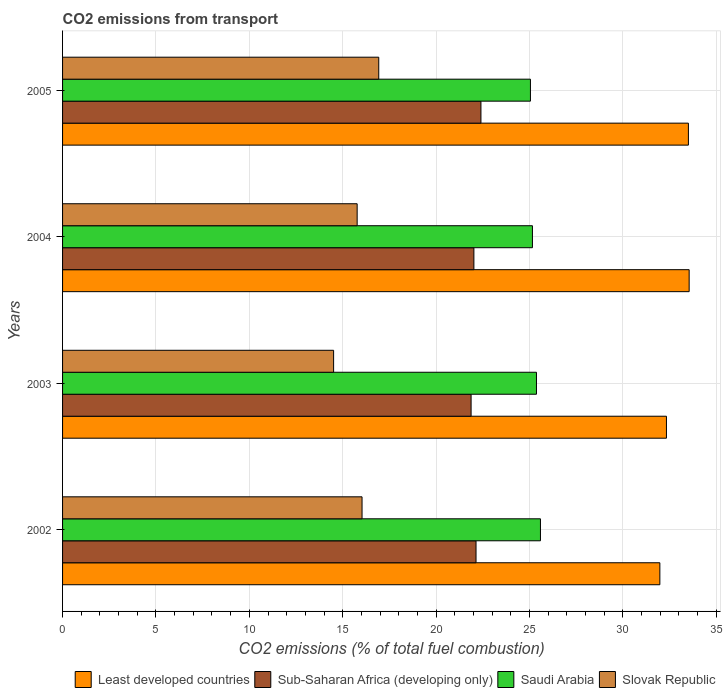How many different coloured bars are there?
Offer a terse response. 4. Are the number of bars per tick equal to the number of legend labels?
Keep it short and to the point. Yes. Are the number of bars on each tick of the Y-axis equal?
Your response must be concise. Yes. How many bars are there on the 1st tick from the top?
Give a very brief answer. 4. How many bars are there on the 2nd tick from the bottom?
Keep it short and to the point. 4. What is the label of the 4th group of bars from the top?
Your response must be concise. 2002. In how many cases, is the number of bars for a given year not equal to the number of legend labels?
Keep it short and to the point. 0. What is the total CO2 emitted in Sub-Saharan Africa (developing only) in 2002?
Your response must be concise. 22.14. Across all years, what is the maximum total CO2 emitted in Slovak Republic?
Give a very brief answer. 16.93. Across all years, what is the minimum total CO2 emitted in Sub-Saharan Africa (developing only)?
Keep it short and to the point. 21.87. In which year was the total CO2 emitted in Sub-Saharan Africa (developing only) maximum?
Offer a very short reply. 2005. In which year was the total CO2 emitted in Least developed countries minimum?
Your answer should be compact. 2002. What is the total total CO2 emitted in Sub-Saharan Africa (developing only) in the graph?
Ensure brevity in your answer.  88.43. What is the difference between the total CO2 emitted in Saudi Arabia in 2002 and that in 2004?
Your response must be concise. 0.43. What is the difference between the total CO2 emitted in Saudi Arabia in 2005 and the total CO2 emitted in Slovak Republic in 2003?
Your answer should be compact. 10.54. What is the average total CO2 emitted in Sub-Saharan Africa (developing only) per year?
Offer a very short reply. 22.11. In the year 2004, what is the difference between the total CO2 emitted in Sub-Saharan Africa (developing only) and total CO2 emitted in Least developed countries?
Make the answer very short. -11.53. In how many years, is the total CO2 emitted in Saudi Arabia greater than 23 ?
Keep it short and to the point. 4. What is the ratio of the total CO2 emitted in Sub-Saharan Africa (developing only) in 2003 to that in 2004?
Keep it short and to the point. 0.99. Is the total CO2 emitted in Slovak Republic in 2002 less than that in 2004?
Your answer should be very brief. No. What is the difference between the highest and the second highest total CO2 emitted in Saudi Arabia?
Your response must be concise. 0.21. What is the difference between the highest and the lowest total CO2 emitted in Slovak Republic?
Provide a succinct answer. 2.42. Is the sum of the total CO2 emitted in Saudi Arabia in 2002 and 2003 greater than the maximum total CO2 emitted in Slovak Republic across all years?
Make the answer very short. Yes. Is it the case that in every year, the sum of the total CO2 emitted in Saudi Arabia and total CO2 emitted in Least developed countries is greater than the sum of total CO2 emitted in Slovak Republic and total CO2 emitted in Sub-Saharan Africa (developing only)?
Provide a short and direct response. No. What does the 1st bar from the top in 2004 represents?
Make the answer very short. Slovak Republic. What does the 3rd bar from the bottom in 2003 represents?
Provide a succinct answer. Saudi Arabia. Is it the case that in every year, the sum of the total CO2 emitted in Least developed countries and total CO2 emitted in Sub-Saharan Africa (developing only) is greater than the total CO2 emitted in Slovak Republic?
Provide a short and direct response. Yes. How many years are there in the graph?
Provide a short and direct response. 4. Where does the legend appear in the graph?
Your answer should be very brief. Bottom right. How many legend labels are there?
Offer a terse response. 4. What is the title of the graph?
Ensure brevity in your answer.  CO2 emissions from transport. What is the label or title of the X-axis?
Give a very brief answer. CO2 emissions (% of total fuel combustion). What is the CO2 emissions (% of total fuel combustion) of Least developed countries in 2002?
Your response must be concise. 31.98. What is the CO2 emissions (% of total fuel combustion) in Sub-Saharan Africa (developing only) in 2002?
Offer a terse response. 22.14. What is the CO2 emissions (% of total fuel combustion) in Saudi Arabia in 2002?
Your response must be concise. 25.59. What is the CO2 emissions (% of total fuel combustion) of Slovak Republic in 2002?
Make the answer very short. 16.03. What is the CO2 emissions (% of total fuel combustion) in Least developed countries in 2003?
Provide a succinct answer. 32.33. What is the CO2 emissions (% of total fuel combustion) of Sub-Saharan Africa (developing only) in 2003?
Offer a terse response. 21.87. What is the CO2 emissions (% of total fuel combustion) in Saudi Arabia in 2003?
Provide a short and direct response. 25.37. What is the CO2 emissions (% of total fuel combustion) in Slovak Republic in 2003?
Ensure brevity in your answer.  14.51. What is the CO2 emissions (% of total fuel combustion) in Least developed countries in 2004?
Your answer should be compact. 33.55. What is the CO2 emissions (% of total fuel combustion) of Sub-Saharan Africa (developing only) in 2004?
Provide a short and direct response. 22.02. What is the CO2 emissions (% of total fuel combustion) of Saudi Arabia in 2004?
Keep it short and to the point. 25.16. What is the CO2 emissions (% of total fuel combustion) of Slovak Republic in 2004?
Make the answer very short. 15.77. What is the CO2 emissions (% of total fuel combustion) of Least developed countries in 2005?
Your answer should be very brief. 33.51. What is the CO2 emissions (% of total fuel combustion) of Sub-Saharan Africa (developing only) in 2005?
Your answer should be compact. 22.4. What is the CO2 emissions (% of total fuel combustion) in Saudi Arabia in 2005?
Offer a very short reply. 25.05. What is the CO2 emissions (% of total fuel combustion) of Slovak Republic in 2005?
Offer a very short reply. 16.93. Across all years, what is the maximum CO2 emissions (% of total fuel combustion) in Least developed countries?
Offer a very short reply. 33.55. Across all years, what is the maximum CO2 emissions (% of total fuel combustion) in Sub-Saharan Africa (developing only)?
Offer a terse response. 22.4. Across all years, what is the maximum CO2 emissions (% of total fuel combustion) of Saudi Arabia?
Provide a short and direct response. 25.59. Across all years, what is the maximum CO2 emissions (% of total fuel combustion) in Slovak Republic?
Keep it short and to the point. 16.93. Across all years, what is the minimum CO2 emissions (% of total fuel combustion) of Least developed countries?
Offer a terse response. 31.98. Across all years, what is the minimum CO2 emissions (% of total fuel combustion) of Sub-Saharan Africa (developing only)?
Provide a succinct answer. 21.87. Across all years, what is the minimum CO2 emissions (% of total fuel combustion) in Saudi Arabia?
Ensure brevity in your answer.  25.05. Across all years, what is the minimum CO2 emissions (% of total fuel combustion) of Slovak Republic?
Provide a succinct answer. 14.51. What is the total CO2 emissions (% of total fuel combustion) in Least developed countries in the graph?
Ensure brevity in your answer.  131.37. What is the total CO2 emissions (% of total fuel combustion) in Sub-Saharan Africa (developing only) in the graph?
Your answer should be very brief. 88.43. What is the total CO2 emissions (% of total fuel combustion) of Saudi Arabia in the graph?
Your answer should be compact. 101.17. What is the total CO2 emissions (% of total fuel combustion) of Slovak Republic in the graph?
Provide a succinct answer. 63.25. What is the difference between the CO2 emissions (% of total fuel combustion) of Least developed countries in 2002 and that in 2003?
Your answer should be compact. -0.35. What is the difference between the CO2 emissions (% of total fuel combustion) of Sub-Saharan Africa (developing only) in 2002 and that in 2003?
Your response must be concise. 0.26. What is the difference between the CO2 emissions (% of total fuel combustion) of Saudi Arabia in 2002 and that in 2003?
Your response must be concise. 0.21. What is the difference between the CO2 emissions (% of total fuel combustion) in Slovak Republic in 2002 and that in 2003?
Your answer should be very brief. 1.52. What is the difference between the CO2 emissions (% of total fuel combustion) in Least developed countries in 2002 and that in 2004?
Offer a terse response. -1.57. What is the difference between the CO2 emissions (% of total fuel combustion) in Sub-Saharan Africa (developing only) in 2002 and that in 2004?
Provide a short and direct response. 0.11. What is the difference between the CO2 emissions (% of total fuel combustion) of Saudi Arabia in 2002 and that in 2004?
Keep it short and to the point. 0.43. What is the difference between the CO2 emissions (% of total fuel combustion) of Slovak Republic in 2002 and that in 2004?
Offer a terse response. 0.26. What is the difference between the CO2 emissions (% of total fuel combustion) of Least developed countries in 2002 and that in 2005?
Offer a very short reply. -1.53. What is the difference between the CO2 emissions (% of total fuel combustion) in Sub-Saharan Africa (developing only) in 2002 and that in 2005?
Offer a very short reply. -0.26. What is the difference between the CO2 emissions (% of total fuel combustion) of Saudi Arabia in 2002 and that in 2005?
Ensure brevity in your answer.  0.54. What is the difference between the CO2 emissions (% of total fuel combustion) of Slovak Republic in 2002 and that in 2005?
Provide a short and direct response. -0.89. What is the difference between the CO2 emissions (% of total fuel combustion) of Least developed countries in 2003 and that in 2004?
Keep it short and to the point. -1.22. What is the difference between the CO2 emissions (% of total fuel combustion) in Sub-Saharan Africa (developing only) in 2003 and that in 2004?
Keep it short and to the point. -0.15. What is the difference between the CO2 emissions (% of total fuel combustion) of Saudi Arabia in 2003 and that in 2004?
Provide a succinct answer. 0.22. What is the difference between the CO2 emissions (% of total fuel combustion) in Slovak Republic in 2003 and that in 2004?
Provide a short and direct response. -1.26. What is the difference between the CO2 emissions (% of total fuel combustion) of Least developed countries in 2003 and that in 2005?
Ensure brevity in your answer.  -1.18. What is the difference between the CO2 emissions (% of total fuel combustion) of Sub-Saharan Africa (developing only) in 2003 and that in 2005?
Keep it short and to the point. -0.53. What is the difference between the CO2 emissions (% of total fuel combustion) of Saudi Arabia in 2003 and that in 2005?
Make the answer very short. 0.32. What is the difference between the CO2 emissions (% of total fuel combustion) of Slovak Republic in 2003 and that in 2005?
Give a very brief answer. -2.42. What is the difference between the CO2 emissions (% of total fuel combustion) of Least developed countries in 2004 and that in 2005?
Provide a short and direct response. 0.04. What is the difference between the CO2 emissions (% of total fuel combustion) of Sub-Saharan Africa (developing only) in 2004 and that in 2005?
Make the answer very short. -0.38. What is the difference between the CO2 emissions (% of total fuel combustion) in Saudi Arabia in 2004 and that in 2005?
Provide a succinct answer. 0.11. What is the difference between the CO2 emissions (% of total fuel combustion) of Slovak Republic in 2004 and that in 2005?
Provide a succinct answer. -1.16. What is the difference between the CO2 emissions (% of total fuel combustion) in Least developed countries in 2002 and the CO2 emissions (% of total fuel combustion) in Sub-Saharan Africa (developing only) in 2003?
Offer a very short reply. 10.11. What is the difference between the CO2 emissions (% of total fuel combustion) of Least developed countries in 2002 and the CO2 emissions (% of total fuel combustion) of Saudi Arabia in 2003?
Your answer should be compact. 6.61. What is the difference between the CO2 emissions (% of total fuel combustion) of Least developed countries in 2002 and the CO2 emissions (% of total fuel combustion) of Slovak Republic in 2003?
Keep it short and to the point. 17.47. What is the difference between the CO2 emissions (% of total fuel combustion) in Sub-Saharan Africa (developing only) in 2002 and the CO2 emissions (% of total fuel combustion) in Saudi Arabia in 2003?
Offer a very short reply. -3.24. What is the difference between the CO2 emissions (% of total fuel combustion) of Sub-Saharan Africa (developing only) in 2002 and the CO2 emissions (% of total fuel combustion) of Slovak Republic in 2003?
Make the answer very short. 7.62. What is the difference between the CO2 emissions (% of total fuel combustion) of Saudi Arabia in 2002 and the CO2 emissions (% of total fuel combustion) of Slovak Republic in 2003?
Your answer should be compact. 11.07. What is the difference between the CO2 emissions (% of total fuel combustion) of Least developed countries in 2002 and the CO2 emissions (% of total fuel combustion) of Sub-Saharan Africa (developing only) in 2004?
Offer a terse response. 9.96. What is the difference between the CO2 emissions (% of total fuel combustion) in Least developed countries in 2002 and the CO2 emissions (% of total fuel combustion) in Saudi Arabia in 2004?
Your answer should be compact. 6.82. What is the difference between the CO2 emissions (% of total fuel combustion) of Least developed countries in 2002 and the CO2 emissions (% of total fuel combustion) of Slovak Republic in 2004?
Offer a terse response. 16.21. What is the difference between the CO2 emissions (% of total fuel combustion) in Sub-Saharan Africa (developing only) in 2002 and the CO2 emissions (% of total fuel combustion) in Saudi Arabia in 2004?
Make the answer very short. -3.02. What is the difference between the CO2 emissions (% of total fuel combustion) of Sub-Saharan Africa (developing only) in 2002 and the CO2 emissions (% of total fuel combustion) of Slovak Republic in 2004?
Ensure brevity in your answer.  6.36. What is the difference between the CO2 emissions (% of total fuel combustion) in Saudi Arabia in 2002 and the CO2 emissions (% of total fuel combustion) in Slovak Republic in 2004?
Provide a short and direct response. 9.81. What is the difference between the CO2 emissions (% of total fuel combustion) of Least developed countries in 2002 and the CO2 emissions (% of total fuel combustion) of Sub-Saharan Africa (developing only) in 2005?
Your answer should be very brief. 9.58. What is the difference between the CO2 emissions (% of total fuel combustion) in Least developed countries in 2002 and the CO2 emissions (% of total fuel combustion) in Saudi Arabia in 2005?
Provide a succinct answer. 6.93. What is the difference between the CO2 emissions (% of total fuel combustion) of Least developed countries in 2002 and the CO2 emissions (% of total fuel combustion) of Slovak Republic in 2005?
Offer a very short reply. 15.05. What is the difference between the CO2 emissions (% of total fuel combustion) in Sub-Saharan Africa (developing only) in 2002 and the CO2 emissions (% of total fuel combustion) in Saudi Arabia in 2005?
Keep it short and to the point. -2.91. What is the difference between the CO2 emissions (% of total fuel combustion) in Sub-Saharan Africa (developing only) in 2002 and the CO2 emissions (% of total fuel combustion) in Slovak Republic in 2005?
Offer a very short reply. 5.21. What is the difference between the CO2 emissions (% of total fuel combustion) in Saudi Arabia in 2002 and the CO2 emissions (% of total fuel combustion) in Slovak Republic in 2005?
Your answer should be very brief. 8.66. What is the difference between the CO2 emissions (% of total fuel combustion) in Least developed countries in 2003 and the CO2 emissions (% of total fuel combustion) in Sub-Saharan Africa (developing only) in 2004?
Offer a terse response. 10.31. What is the difference between the CO2 emissions (% of total fuel combustion) in Least developed countries in 2003 and the CO2 emissions (% of total fuel combustion) in Saudi Arabia in 2004?
Provide a short and direct response. 7.18. What is the difference between the CO2 emissions (% of total fuel combustion) in Least developed countries in 2003 and the CO2 emissions (% of total fuel combustion) in Slovak Republic in 2004?
Keep it short and to the point. 16.56. What is the difference between the CO2 emissions (% of total fuel combustion) in Sub-Saharan Africa (developing only) in 2003 and the CO2 emissions (% of total fuel combustion) in Saudi Arabia in 2004?
Provide a succinct answer. -3.28. What is the difference between the CO2 emissions (% of total fuel combustion) of Sub-Saharan Africa (developing only) in 2003 and the CO2 emissions (% of total fuel combustion) of Slovak Republic in 2004?
Your answer should be compact. 6.1. What is the difference between the CO2 emissions (% of total fuel combustion) in Saudi Arabia in 2003 and the CO2 emissions (% of total fuel combustion) in Slovak Republic in 2004?
Provide a succinct answer. 9.6. What is the difference between the CO2 emissions (% of total fuel combustion) of Least developed countries in 2003 and the CO2 emissions (% of total fuel combustion) of Sub-Saharan Africa (developing only) in 2005?
Offer a very short reply. 9.93. What is the difference between the CO2 emissions (% of total fuel combustion) in Least developed countries in 2003 and the CO2 emissions (% of total fuel combustion) in Saudi Arabia in 2005?
Keep it short and to the point. 7.28. What is the difference between the CO2 emissions (% of total fuel combustion) of Least developed countries in 2003 and the CO2 emissions (% of total fuel combustion) of Slovak Republic in 2005?
Offer a terse response. 15.4. What is the difference between the CO2 emissions (% of total fuel combustion) of Sub-Saharan Africa (developing only) in 2003 and the CO2 emissions (% of total fuel combustion) of Saudi Arabia in 2005?
Provide a succinct answer. -3.18. What is the difference between the CO2 emissions (% of total fuel combustion) in Sub-Saharan Africa (developing only) in 2003 and the CO2 emissions (% of total fuel combustion) in Slovak Republic in 2005?
Provide a succinct answer. 4.94. What is the difference between the CO2 emissions (% of total fuel combustion) in Saudi Arabia in 2003 and the CO2 emissions (% of total fuel combustion) in Slovak Republic in 2005?
Give a very brief answer. 8.44. What is the difference between the CO2 emissions (% of total fuel combustion) in Least developed countries in 2004 and the CO2 emissions (% of total fuel combustion) in Sub-Saharan Africa (developing only) in 2005?
Your answer should be compact. 11.15. What is the difference between the CO2 emissions (% of total fuel combustion) of Least developed countries in 2004 and the CO2 emissions (% of total fuel combustion) of Saudi Arabia in 2005?
Provide a succinct answer. 8.5. What is the difference between the CO2 emissions (% of total fuel combustion) in Least developed countries in 2004 and the CO2 emissions (% of total fuel combustion) in Slovak Republic in 2005?
Keep it short and to the point. 16.62. What is the difference between the CO2 emissions (% of total fuel combustion) of Sub-Saharan Africa (developing only) in 2004 and the CO2 emissions (% of total fuel combustion) of Saudi Arabia in 2005?
Give a very brief answer. -3.03. What is the difference between the CO2 emissions (% of total fuel combustion) in Sub-Saharan Africa (developing only) in 2004 and the CO2 emissions (% of total fuel combustion) in Slovak Republic in 2005?
Give a very brief answer. 5.09. What is the difference between the CO2 emissions (% of total fuel combustion) in Saudi Arabia in 2004 and the CO2 emissions (% of total fuel combustion) in Slovak Republic in 2005?
Provide a succinct answer. 8.23. What is the average CO2 emissions (% of total fuel combustion) in Least developed countries per year?
Give a very brief answer. 32.84. What is the average CO2 emissions (% of total fuel combustion) in Sub-Saharan Africa (developing only) per year?
Keep it short and to the point. 22.11. What is the average CO2 emissions (% of total fuel combustion) of Saudi Arabia per year?
Keep it short and to the point. 25.29. What is the average CO2 emissions (% of total fuel combustion) in Slovak Republic per year?
Make the answer very short. 15.81. In the year 2002, what is the difference between the CO2 emissions (% of total fuel combustion) in Least developed countries and CO2 emissions (% of total fuel combustion) in Sub-Saharan Africa (developing only)?
Provide a short and direct response. 9.84. In the year 2002, what is the difference between the CO2 emissions (% of total fuel combustion) in Least developed countries and CO2 emissions (% of total fuel combustion) in Saudi Arabia?
Your response must be concise. 6.39. In the year 2002, what is the difference between the CO2 emissions (% of total fuel combustion) of Least developed countries and CO2 emissions (% of total fuel combustion) of Slovak Republic?
Your answer should be compact. 15.95. In the year 2002, what is the difference between the CO2 emissions (% of total fuel combustion) of Sub-Saharan Africa (developing only) and CO2 emissions (% of total fuel combustion) of Saudi Arabia?
Make the answer very short. -3.45. In the year 2002, what is the difference between the CO2 emissions (% of total fuel combustion) of Sub-Saharan Africa (developing only) and CO2 emissions (% of total fuel combustion) of Slovak Republic?
Ensure brevity in your answer.  6.1. In the year 2002, what is the difference between the CO2 emissions (% of total fuel combustion) of Saudi Arabia and CO2 emissions (% of total fuel combustion) of Slovak Republic?
Offer a terse response. 9.55. In the year 2003, what is the difference between the CO2 emissions (% of total fuel combustion) of Least developed countries and CO2 emissions (% of total fuel combustion) of Sub-Saharan Africa (developing only)?
Keep it short and to the point. 10.46. In the year 2003, what is the difference between the CO2 emissions (% of total fuel combustion) in Least developed countries and CO2 emissions (% of total fuel combustion) in Saudi Arabia?
Offer a very short reply. 6.96. In the year 2003, what is the difference between the CO2 emissions (% of total fuel combustion) in Least developed countries and CO2 emissions (% of total fuel combustion) in Slovak Republic?
Your answer should be very brief. 17.82. In the year 2003, what is the difference between the CO2 emissions (% of total fuel combustion) in Sub-Saharan Africa (developing only) and CO2 emissions (% of total fuel combustion) in Saudi Arabia?
Ensure brevity in your answer.  -3.5. In the year 2003, what is the difference between the CO2 emissions (% of total fuel combustion) in Sub-Saharan Africa (developing only) and CO2 emissions (% of total fuel combustion) in Slovak Republic?
Your answer should be very brief. 7.36. In the year 2003, what is the difference between the CO2 emissions (% of total fuel combustion) of Saudi Arabia and CO2 emissions (% of total fuel combustion) of Slovak Republic?
Provide a short and direct response. 10.86. In the year 2004, what is the difference between the CO2 emissions (% of total fuel combustion) of Least developed countries and CO2 emissions (% of total fuel combustion) of Sub-Saharan Africa (developing only)?
Your answer should be compact. 11.53. In the year 2004, what is the difference between the CO2 emissions (% of total fuel combustion) of Least developed countries and CO2 emissions (% of total fuel combustion) of Saudi Arabia?
Provide a short and direct response. 8.39. In the year 2004, what is the difference between the CO2 emissions (% of total fuel combustion) of Least developed countries and CO2 emissions (% of total fuel combustion) of Slovak Republic?
Provide a short and direct response. 17.78. In the year 2004, what is the difference between the CO2 emissions (% of total fuel combustion) in Sub-Saharan Africa (developing only) and CO2 emissions (% of total fuel combustion) in Saudi Arabia?
Keep it short and to the point. -3.13. In the year 2004, what is the difference between the CO2 emissions (% of total fuel combustion) of Sub-Saharan Africa (developing only) and CO2 emissions (% of total fuel combustion) of Slovak Republic?
Your answer should be compact. 6.25. In the year 2004, what is the difference between the CO2 emissions (% of total fuel combustion) of Saudi Arabia and CO2 emissions (% of total fuel combustion) of Slovak Republic?
Provide a short and direct response. 9.39. In the year 2005, what is the difference between the CO2 emissions (% of total fuel combustion) in Least developed countries and CO2 emissions (% of total fuel combustion) in Sub-Saharan Africa (developing only)?
Offer a terse response. 11.11. In the year 2005, what is the difference between the CO2 emissions (% of total fuel combustion) in Least developed countries and CO2 emissions (% of total fuel combustion) in Saudi Arabia?
Give a very brief answer. 8.46. In the year 2005, what is the difference between the CO2 emissions (% of total fuel combustion) in Least developed countries and CO2 emissions (% of total fuel combustion) in Slovak Republic?
Offer a very short reply. 16.58. In the year 2005, what is the difference between the CO2 emissions (% of total fuel combustion) in Sub-Saharan Africa (developing only) and CO2 emissions (% of total fuel combustion) in Saudi Arabia?
Keep it short and to the point. -2.65. In the year 2005, what is the difference between the CO2 emissions (% of total fuel combustion) in Sub-Saharan Africa (developing only) and CO2 emissions (% of total fuel combustion) in Slovak Republic?
Your answer should be very brief. 5.47. In the year 2005, what is the difference between the CO2 emissions (% of total fuel combustion) in Saudi Arabia and CO2 emissions (% of total fuel combustion) in Slovak Republic?
Your response must be concise. 8.12. What is the ratio of the CO2 emissions (% of total fuel combustion) of Sub-Saharan Africa (developing only) in 2002 to that in 2003?
Provide a succinct answer. 1.01. What is the ratio of the CO2 emissions (% of total fuel combustion) in Saudi Arabia in 2002 to that in 2003?
Your response must be concise. 1.01. What is the ratio of the CO2 emissions (% of total fuel combustion) in Slovak Republic in 2002 to that in 2003?
Provide a succinct answer. 1.1. What is the ratio of the CO2 emissions (% of total fuel combustion) of Least developed countries in 2002 to that in 2004?
Ensure brevity in your answer.  0.95. What is the ratio of the CO2 emissions (% of total fuel combustion) in Sub-Saharan Africa (developing only) in 2002 to that in 2004?
Keep it short and to the point. 1.01. What is the ratio of the CO2 emissions (% of total fuel combustion) in Saudi Arabia in 2002 to that in 2004?
Make the answer very short. 1.02. What is the ratio of the CO2 emissions (% of total fuel combustion) in Slovak Republic in 2002 to that in 2004?
Make the answer very short. 1.02. What is the ratio of the CO2 emissions (% of total fuel combustion) of Least developed countries in 2002 to that in 2005?
Provide a short and direct response. 0.95. What is the ratio of the CO2 emissions (% of total fuel combustion) in Sub-Saharan Africa (developing only) in 2002 to that in 2005?
Give a very brief answer. 0.99. What is the ratio of the CO2 emissions (% of total fuel combustion) in Saudi Arabia in 2002 to that in 2005?
Offer a terse response. 1.02. What is the ratio of the CO2 emissions (% of total fuel combustion) of Slovak Republic in 2002 to that in 2005?
Your answer should be compact. 0.95. What is the ratio of the CO2 emissions (% of total fuel combustion) in Least developed countries in 2003 to that in 2004?
Give a very brief answer. 0.96. What is the ratio of the CO2 emissions (% of total fuel combustion) of Sub-Saharan Africa (developing only) in 2003 to that in 2004?
Provide a short and direct response. 0.99. What is the ratio of the CO2 emissions (% of total fuel combustion) in Saudi Arabia in 2003 to that in 2004?
Ensure brevity in your answer.  1.01. What is the ratio of the CO2 emissions (% of total fuel combustion) of Slovak Republic in 2003 to that in 2004?
Provide a short and direct response. 0.92. What is the ratio of the CO2 emissions (% of total fuel combustion) of Least developed countries in 2003 to that in 2005?
Your answer should be very brief. 0.96. What is the ratio of the CO2 emissions (% of total fuel combustion) of Sub-Saharan Africa (developing only) in 2003 to that in 2005?
Your response must be concise. 0.98. What is the ratio of the CO2 emissions (% of total fuel combustion) in Saudi Arabia in 2003 to that in 2005?
Offer a very short reply. 1.01. What is the ratio of the CO2 emissions (% of total fuel combustion) in Slovak Republic in 2003 to that in 2005?
Keep it short and to the point. 0.86. What is the ratio of the CO2 emissions (% of total fuel combustion) in Sub-Saharan Africa (developing only) in 2004 to that in 2005?
Offer a terse response. 0.98. What is the ratio of the CO2 emissions (% of total fuel combustion) in Slovak Republic in 2004 to that in 2005?
Make the answer very short. 0.93. What is the difference between the highest and the second highest CO2 emissions (% of total fuel combustion) in Least developed countries?
Offer a very short reply. 0.04. What is the difference between the highest and the second highest CO2 emissions (% of total fuel combustion) in Sub-Saharan Africa (developing only)?
Your answer should be very brief. 0.26. What is the difference between the highest and the second highest CO2 emissions (% of total fuel combustion) in Saudi Arabia?
Provide a short and direct response. 0.21. What is the difference between the highest and the second highest CO2 emissions (% of total fuel combustion) in Slovak Republic?
Keep it short and to the point. 0.89. What is the difference between the highest and the lowest CO2 emissions (% of total fuel combustion) in Least developed countries?
Offer a terse response. 1.57. What is the difference between the highest and the lowest CO2 emissions (% of total fuel combustion) in Sub-Saharan Africa (developing only)?
Your answer should be compact. 0.53. What is the difference between the highest and the lowest CO2 emissions (% of total fuel combustion) of Saudi Arabia?
Provide a succinct answer. 0.54. What is the difference between the highest and the lowest CO2 emissions (% of total fuel combustion) of Slovak Republic?
Make the answer very short. 2.42. 